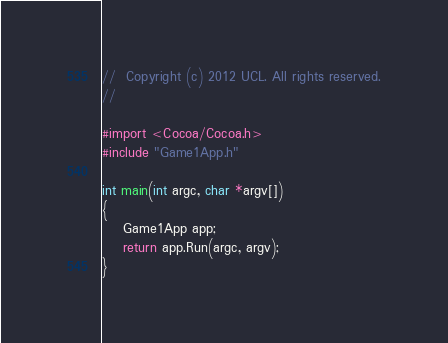Convert code to text. <code><loc_0><loc_0><loc_500><loc_500><_ObjectiveC_>//  Copyright (c) 2012 UCL. All rights reserved.
//

#import <Cocoa/Cocoa.h>
#include "Game1App.h"

int main(int argc, char *argv[])
{
    Game1App app;
    return app.Run(argc, argv);
}
</code> 